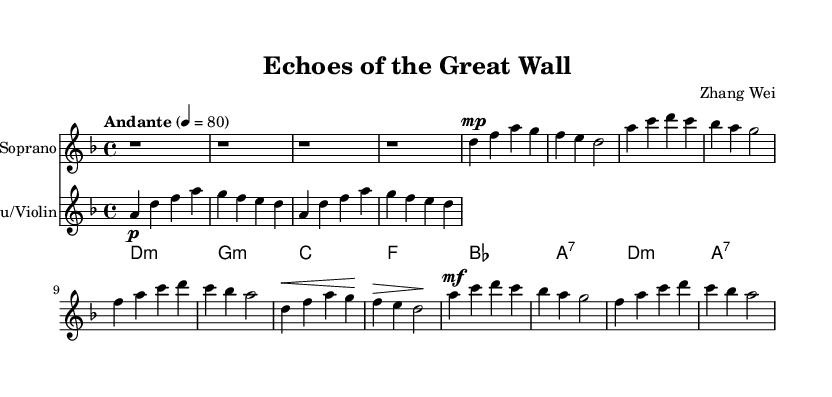What is the key signature of this music? The key signature is D minor, which contains one flat (B flat). This can be determined from the key signature marking located at the beginning of the staff.
Answer: D minor What is the time signature of the piece? The time signature shown is 4/4, which indicates that there are four beats in each measure and that the quarter note receives one beat. This is located at the beginning of the score.
Answer: 4/4 What is the tempo marking for the piece? The tempo marking is "Andante," which typically means to play at a moderately slow pace. This marking is indicated in the tempo section of the score at the beginning.
Answer: Andante How many measures are in the introduction section? The introduction section consists of four measures, as indicated by the four pairs of bar lines contained in the introduction part of the soprano section.
Answer: 4 What dynamic mark is specified for the soprano in the verse? The dynamic marking specified is "mp," which stands for mezzo-piano, indicating a moderately soft volume. This is noted at the beginning of the first verse.
Answer: mp Which instrument plays the first part in the score? The first part in the score is played by the soprano voice, as indicated by the label on the staff. It represents the melodic line with vocal notation.
Answer: Soprano What type of musical form is primarily used in this opera? The primary form used is a combination of verses and a chorus structure, characteristic of opera musical forms that alternate between storytelling (verse) and thematic highlights (chorus). This can be observed from the layout of the music segments.
Answer: Verse and chorus 